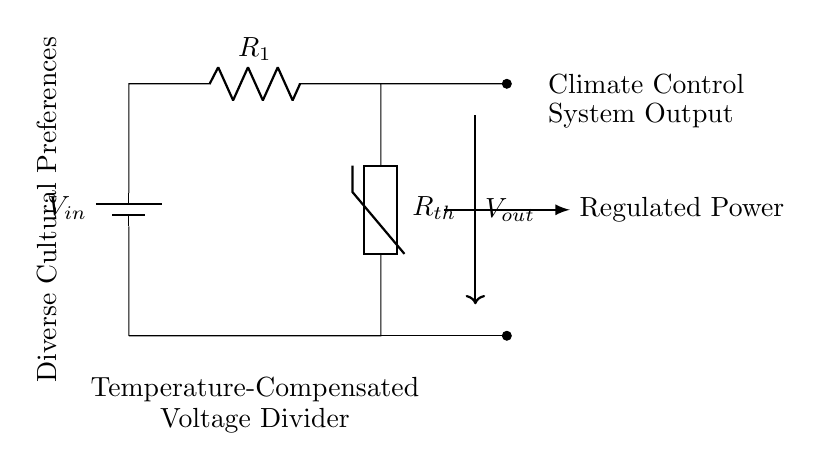What is the input voltage in this circuit? The input voltage is represented by the symbol V_in located next to the battery component in the circuit diagram. Since no specific value is provided in your data, we can only refer to it as V_in.
Answer: V_in What components are involved in this voltage divider? The voltage divider consists of two primary components: a resistor labeled R_1 and a thermistor labeled R_th. These two components are connected in series.
Answer: R_1, R_th What is the output voltage of this circuit represented as? The output voltage is indicated by V_out in the diagram, which is positioned below the arrow pointing downwards from the connection between R_1 and R_th.
Answer: V_out How does temperature affect the thermistor in this circuit? The thermistor is a temperature-sensitive resistor that changes its resistance based on temperature variations. This temperature dependence allows for compensation of voltage output concerning temperature changes, adapting to diverse cultural preferences in climate control.
Answer: It varies the output voltage What is the purpose of the climate control label in relation to this circuit? The climate control label shows that the regulated output voltage, V_out, is intended for a climate control system. It indicates that the voltage divider's output is used to provide power to systems that adjust environmental conditions according to different cultural preferences.
Answer: Regulated power What connection type is used between R_1 and the thermistor? The circuit shows that R_1 and R_th are connected in series, which is typical for a voltage divider configuration as it allows for the output voltage to be derived based on the resistor values.
Answer: Series connection What does the label "Diverse Cultural Preferences" imply in this circuit? The label indicates that the voltage divider system is designed to accommodate various temperature settings and adjustments tailored to meet different cultural preferences regarding climate control, suggesting an emphasis on creating a responsive environment.
Answer: Tailored adjustments 